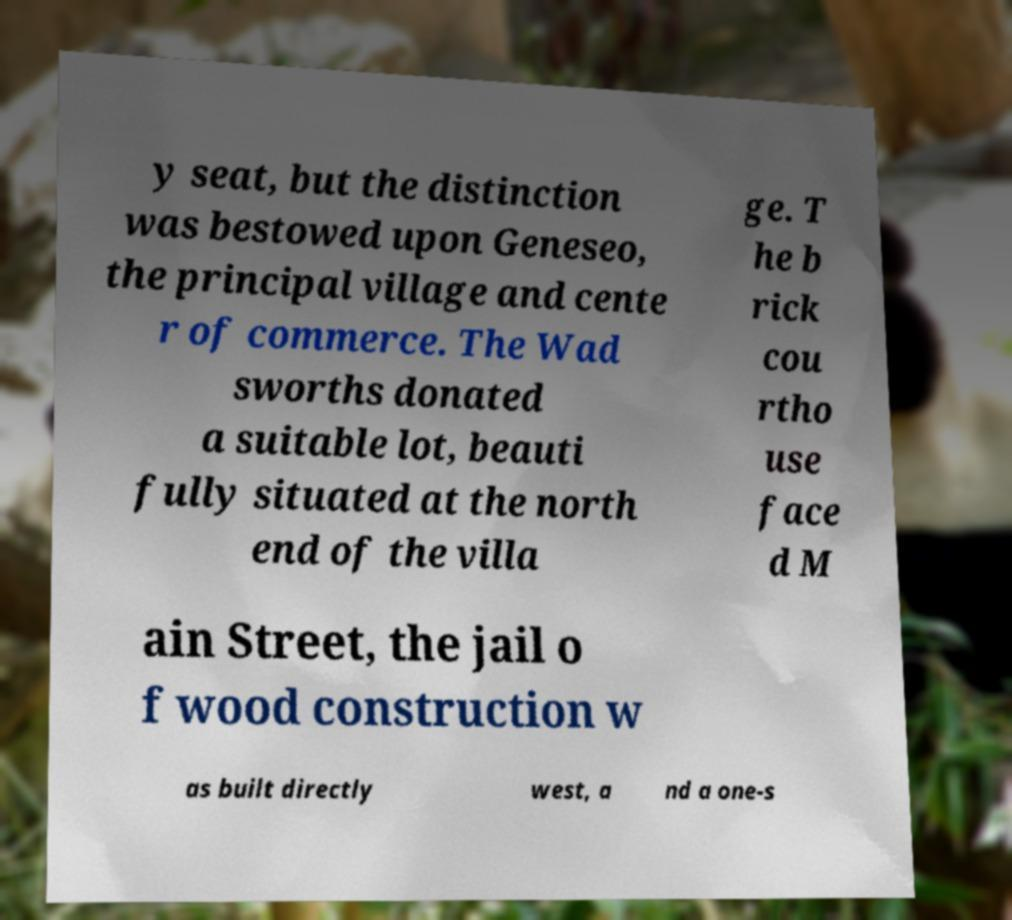Could you assist in decoding the text presented in this image and type it out clearly? y seat, but the distinction was bestowed upon Geneseo, the principal village and cente r of commerce. The Wad sworths donated a suitable lot, beauti fully situated at the north end of the villa ge. T he b rick cou rtho use face d M ain Street, the jail o f wood construction w as built directly west, a nd a one-s 